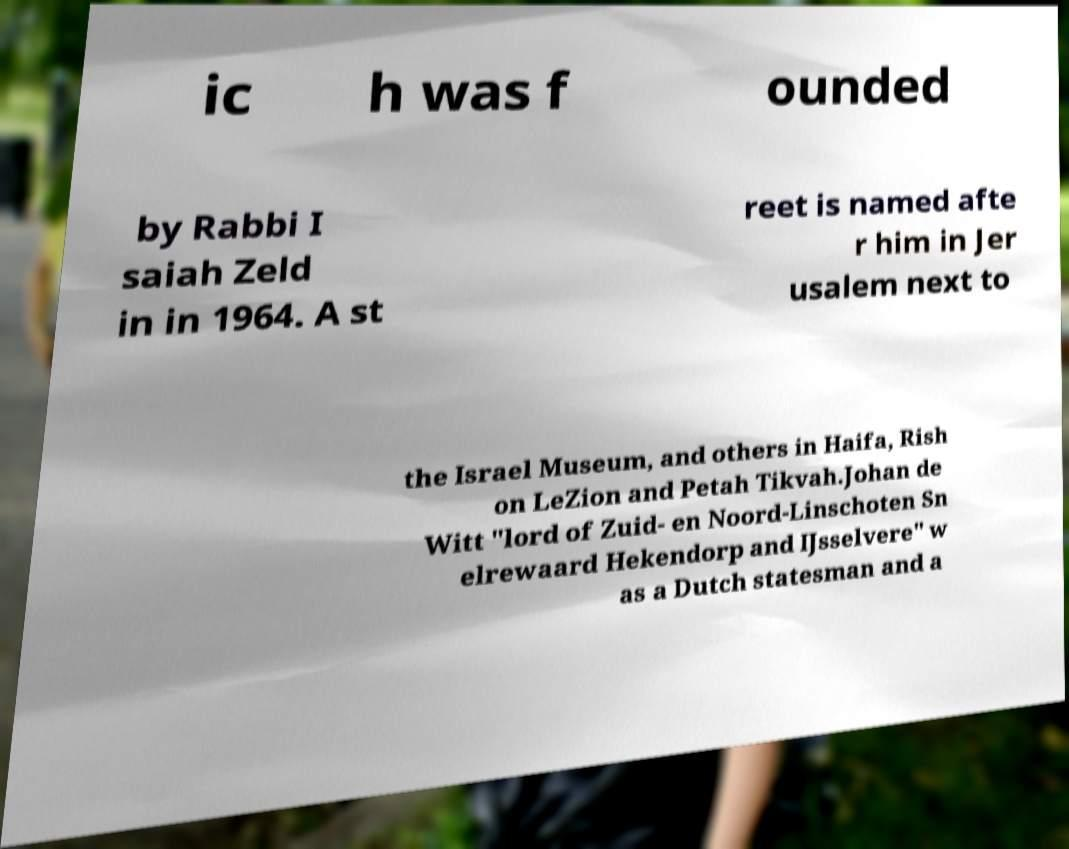Could you extract and type out the text from this image? ic h was f ounded by Rabbi I saiah Zeld in in 1964. A st reet is named afte r him in Jer usalem next to the Israel Museum, and others in Haifa, Rish on LeZion and Petah Tikvah.Johan de Witt "lord of Zuid- en Noord-Linschoten Sn elrewaard Hekendorp and IJsselvere" w as a Dutch statesman and a 